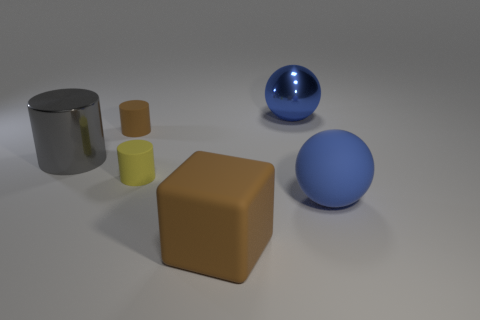Add 4 blue metallic objects. How many objects exist? 10 Subtract all blocks. How many objects are left? 5 Subtract 0 cyan cubes. How many objects are left? 6 Subtract all big blue rubber spheres. Subtract all large yellow metal cylinders. How many objects are left? 5 Add 5 large blue spheres. How many large blue spheres are left? 7 Add 2 big gray balls. How many big gray balls exist? 2 